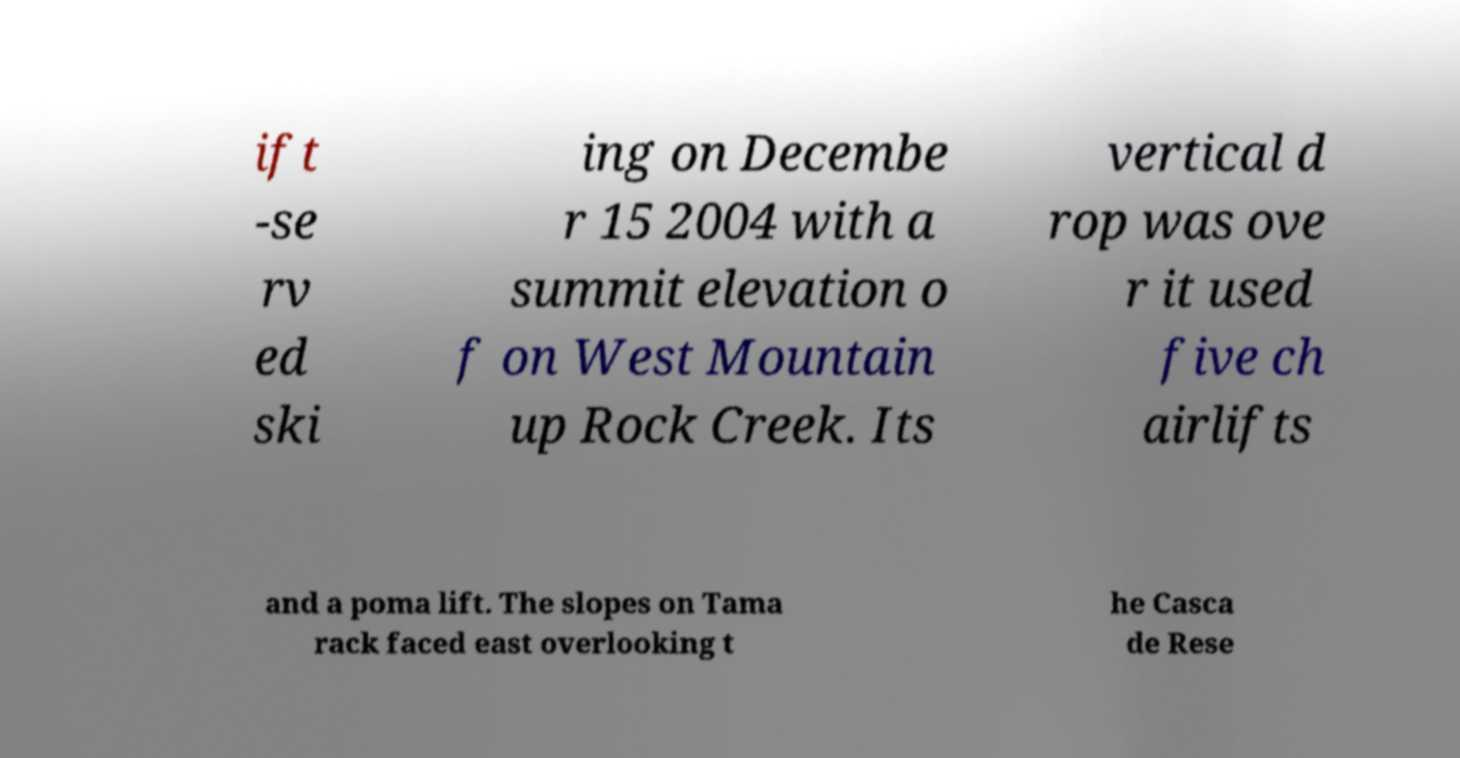Can you read and provide the text displayed in the image?This photo seems to have some interesting text. Can you extract and type it out for me? ift -se rv ed ski ing on Decembe r 15 2004 with a summit elevation o f on West Mountain up Rock Creek. Its vertical d rop was ove r it used five ch airlifts and a poma lift. The slopes on Tama rack faced east overlooking t he Casca de Rese 